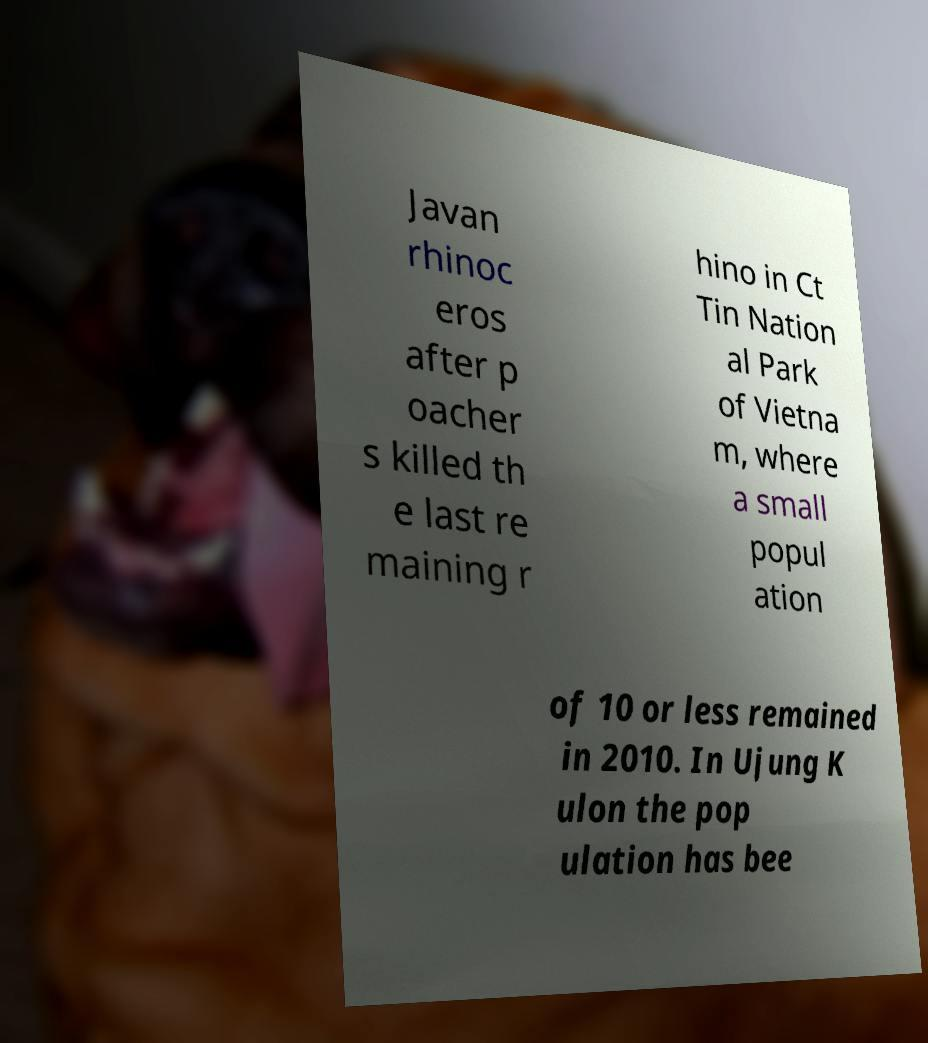I need the written content from this picture converted into text. Can you do that? Javan rhinoc eros after p oacher s killed th e last re maining r hino in Ct Tin Nation al Park of Vietna m, where a small popul ation of 10 or less remained in 2010. In Ujung K ulon the pop ulation has bee 